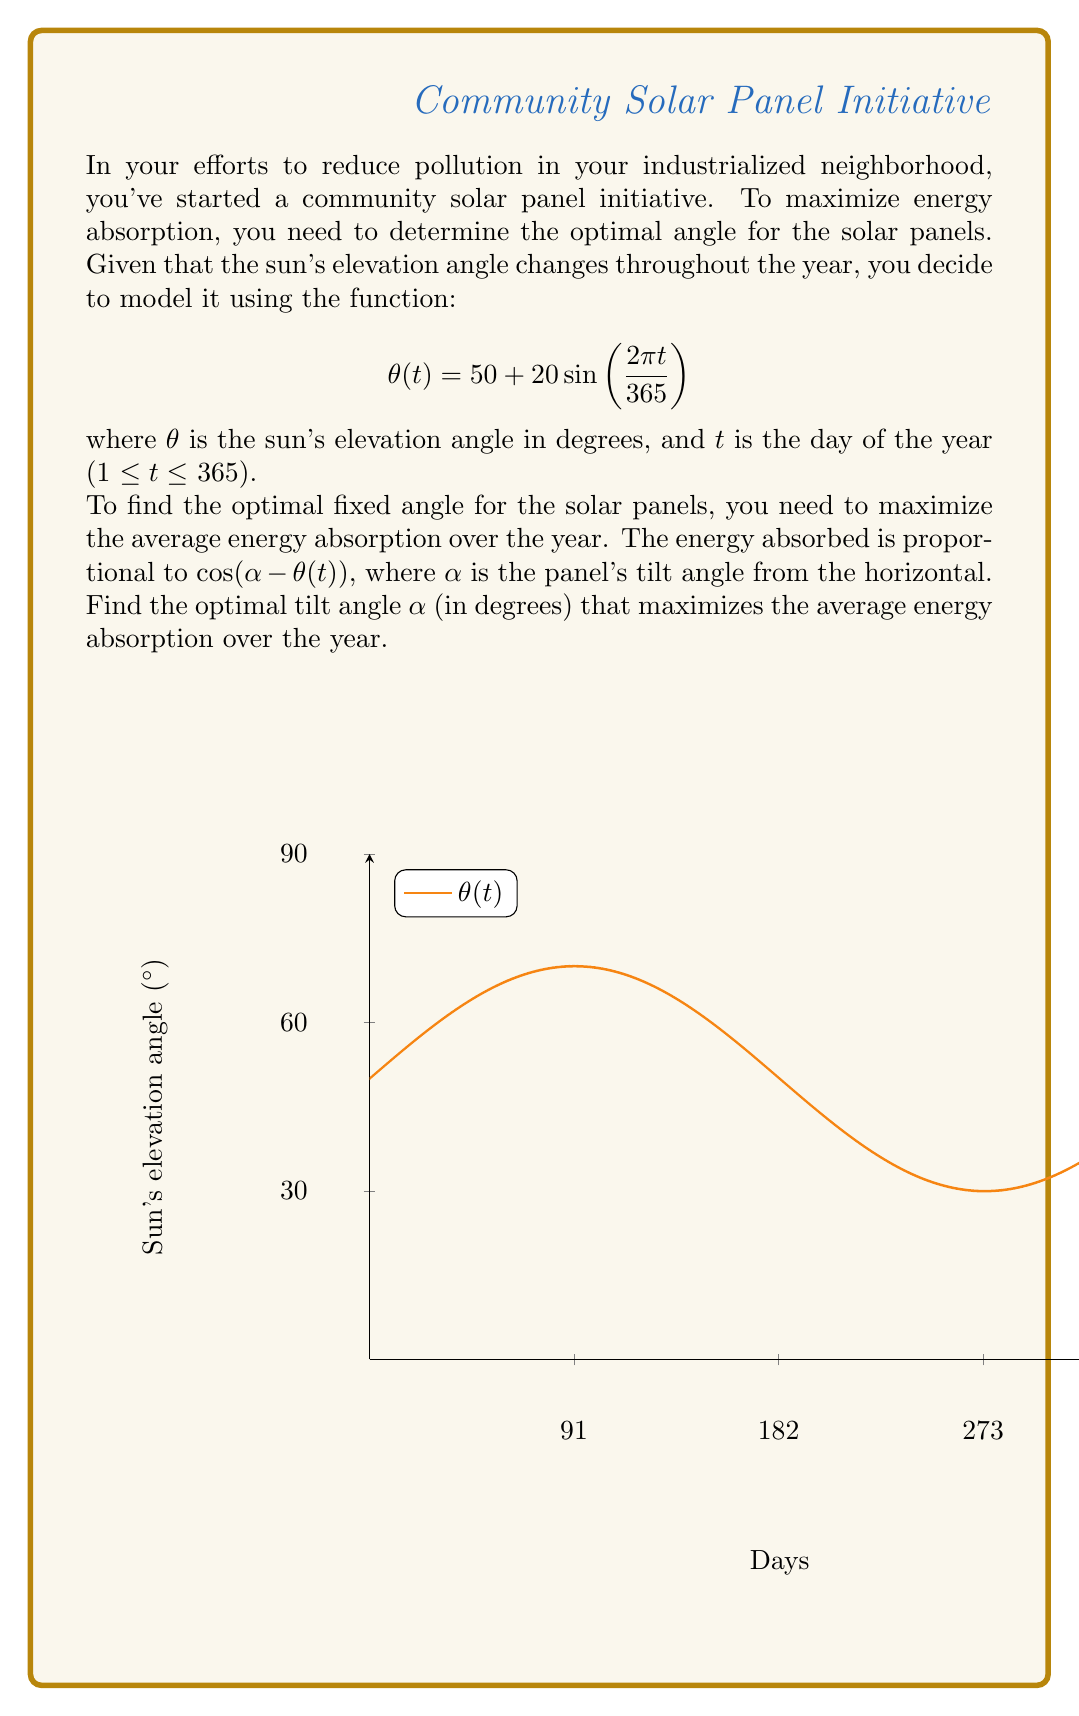Can you answer this question? To solve this problem, we need to follow these steps:

1) The average energy absorption over the year is proportional to:

   $$E(\alpha) = \frac{1}{365}\int_0^{365} \cos(\alpha - \theta(t)) dt$$

2) To maximize this, we need to find where its derivative with respect to $\alpha$ is zero:

   $$\frac{dE}{d\alpha} = -\frac{1}{365}\int_0^{365} \sin(\alpha - \theta(t)) dt = 0$$

3) Expanding $\theta(t)$:

   $$\frac{1}{365}\int_0^{365} \sin(\alpha - 50 - 20\sin(\frac{2\pi t}{365})) dt = 0$$

4) This integral is complex, but we can use the fact that $\sin(A-B) = \sin A \cos B - \cos A \sin B$:

   $$\sin(\alpha - 50)\cdot\frac{1}{365}\int_0^{365} \cos(20\sin(\frac{2\pi t}{365})) dt - \cos(\alpha - 50)\cdot\frac{1}{365}\int_0^{365} \sin(20\sin(\frac{2\pi t}{365})) dt = 0$$

5) The second integral is zero due to symmetry. The first integral is a constant (let's call it $C$). So we have:

   $$\sin(\alpha - 50) \cdot C = 0$$

6) This is satisfied when $\alpha - 50 = 0$, or $\alpha = 50$.

7) To confirm this is a maximum, we can check the second derivative is negative at this point.

Therefore, the optimal tilt angle is 50°, which is equal to the average elevation angle of the sun over the year.
Answer: 50° 